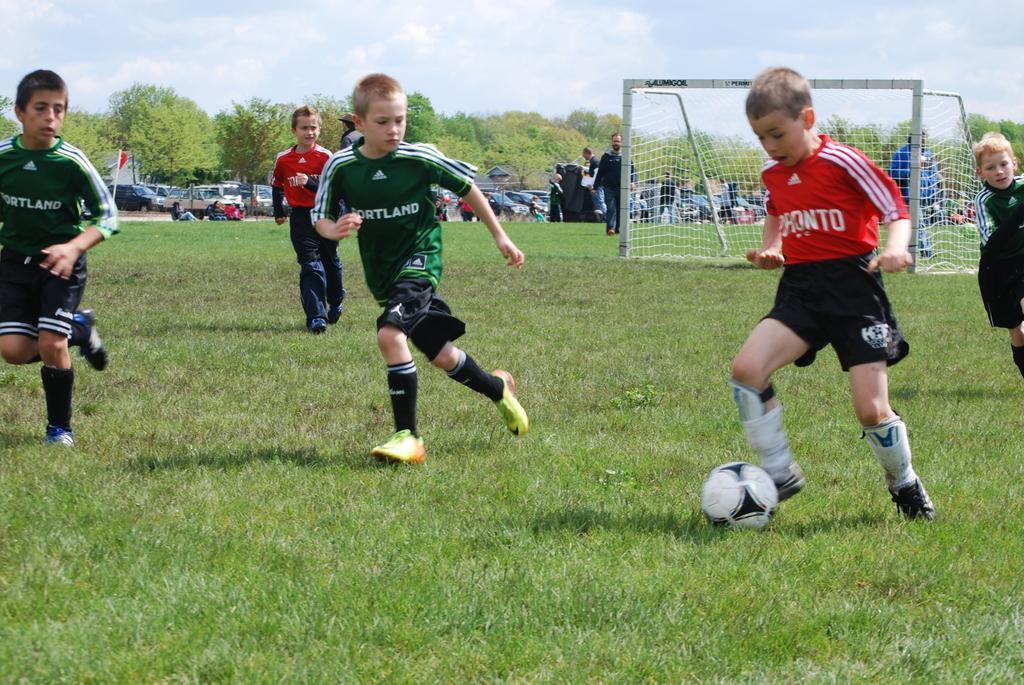Please provide a concise description of this image. In this picture we can see group of people, few kids are playing game in the ground, in the background we can see a net, couple of vehicles and couple of trees. 